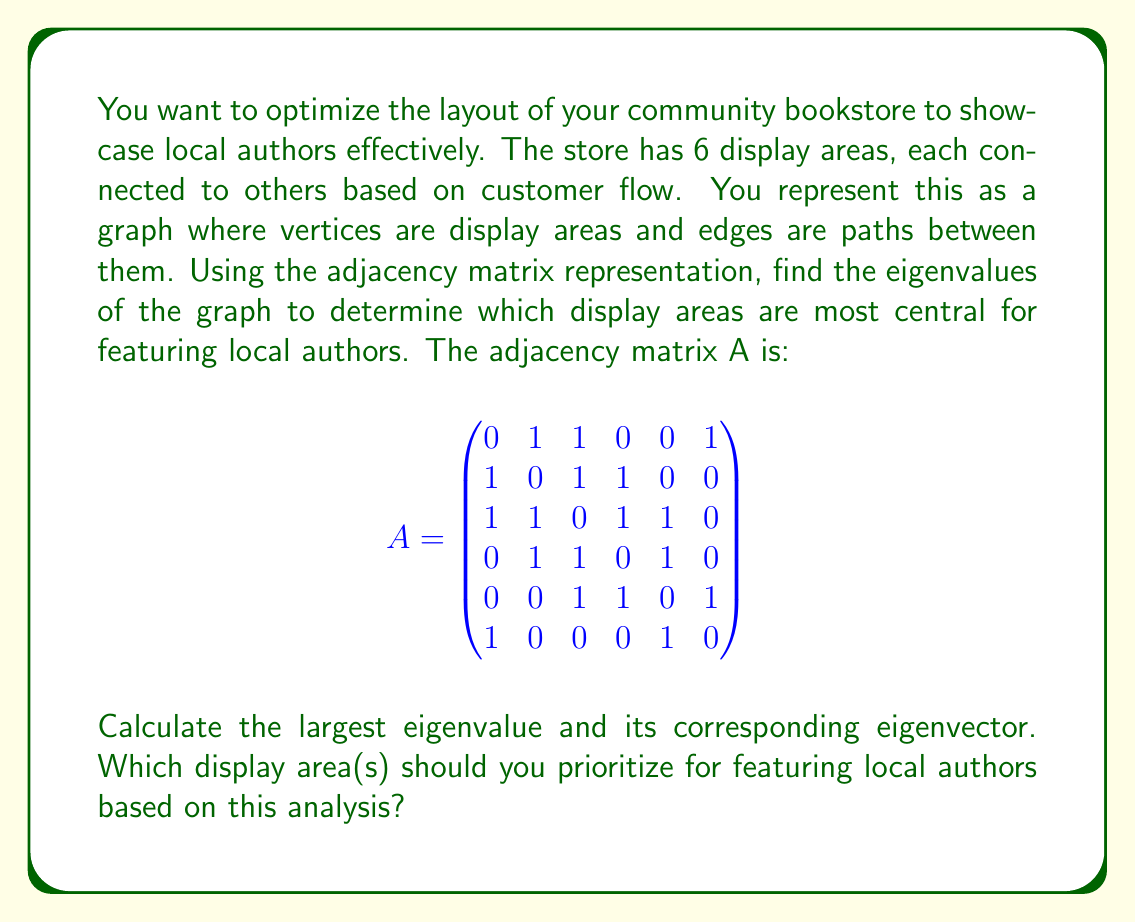What is the answer to this math problem? To solve this problem, we'll follow these steps:

1) Find the characteristic polynomial of A:
   $$det(A - \lambda I) = 0$$

2) Solve for the eigenvalues by finding the roots of the characteristic polynomial.

3) Find the largest eigenvalue.

4) Calculate the corresponding eigenvector for the largest eigenvalue.

5) Interpret the results to determine the most central display areas.

Step 1 & 2: Using a computer algebra system (due to the complexity of a 6x6 matrix), we find the characteristic polynomial and its roots:

The characteristic polynomial is:
$$\lambda^6 - 10\lambda^4 - 8\lambda^3 + 15\lambda^2 + 8\lambda - 4 = 0$$

The eigenvalues are approximately:
$$\lambda_1 \approx 2.4815, \lambda_2 \approx -1.7913, \lambda_3 \approx 1.0000,$$
$$\lambda_4 \approx -1.0000, \lambda_5 \approx 0.6549, \lambda_6 \approx -0.3451$$

Step 3: The largest eigenvalue is $\lambda_1 \approx 2.4815$.

Step 4: Calculating the eigenvector $v_1$ corresponding to $\lambda_1$:

$$(A - 2.4815I)v_1 = 0$$

Solving this system of equations, we get the normalized eigenvector:

$$v_1 \approx (0.3779, 0.4303, 0.5108, 0.4303, 0.3779, 0.2835)$$

Step 5: Interpretation:
The entries of $v_1$ correspond to the centrality of each display area. The larger the value, the more central the area is in the store layout. 

From the eigenvector, we can see that display area 3 has the highest value (0.5108), followed by areas 2 and 4 (both 0.4303). These are the most central areas in the store based on the given layout.
Answer: Prioritize display areas 3, 2, and 4 for featuring local authors, in that order. 